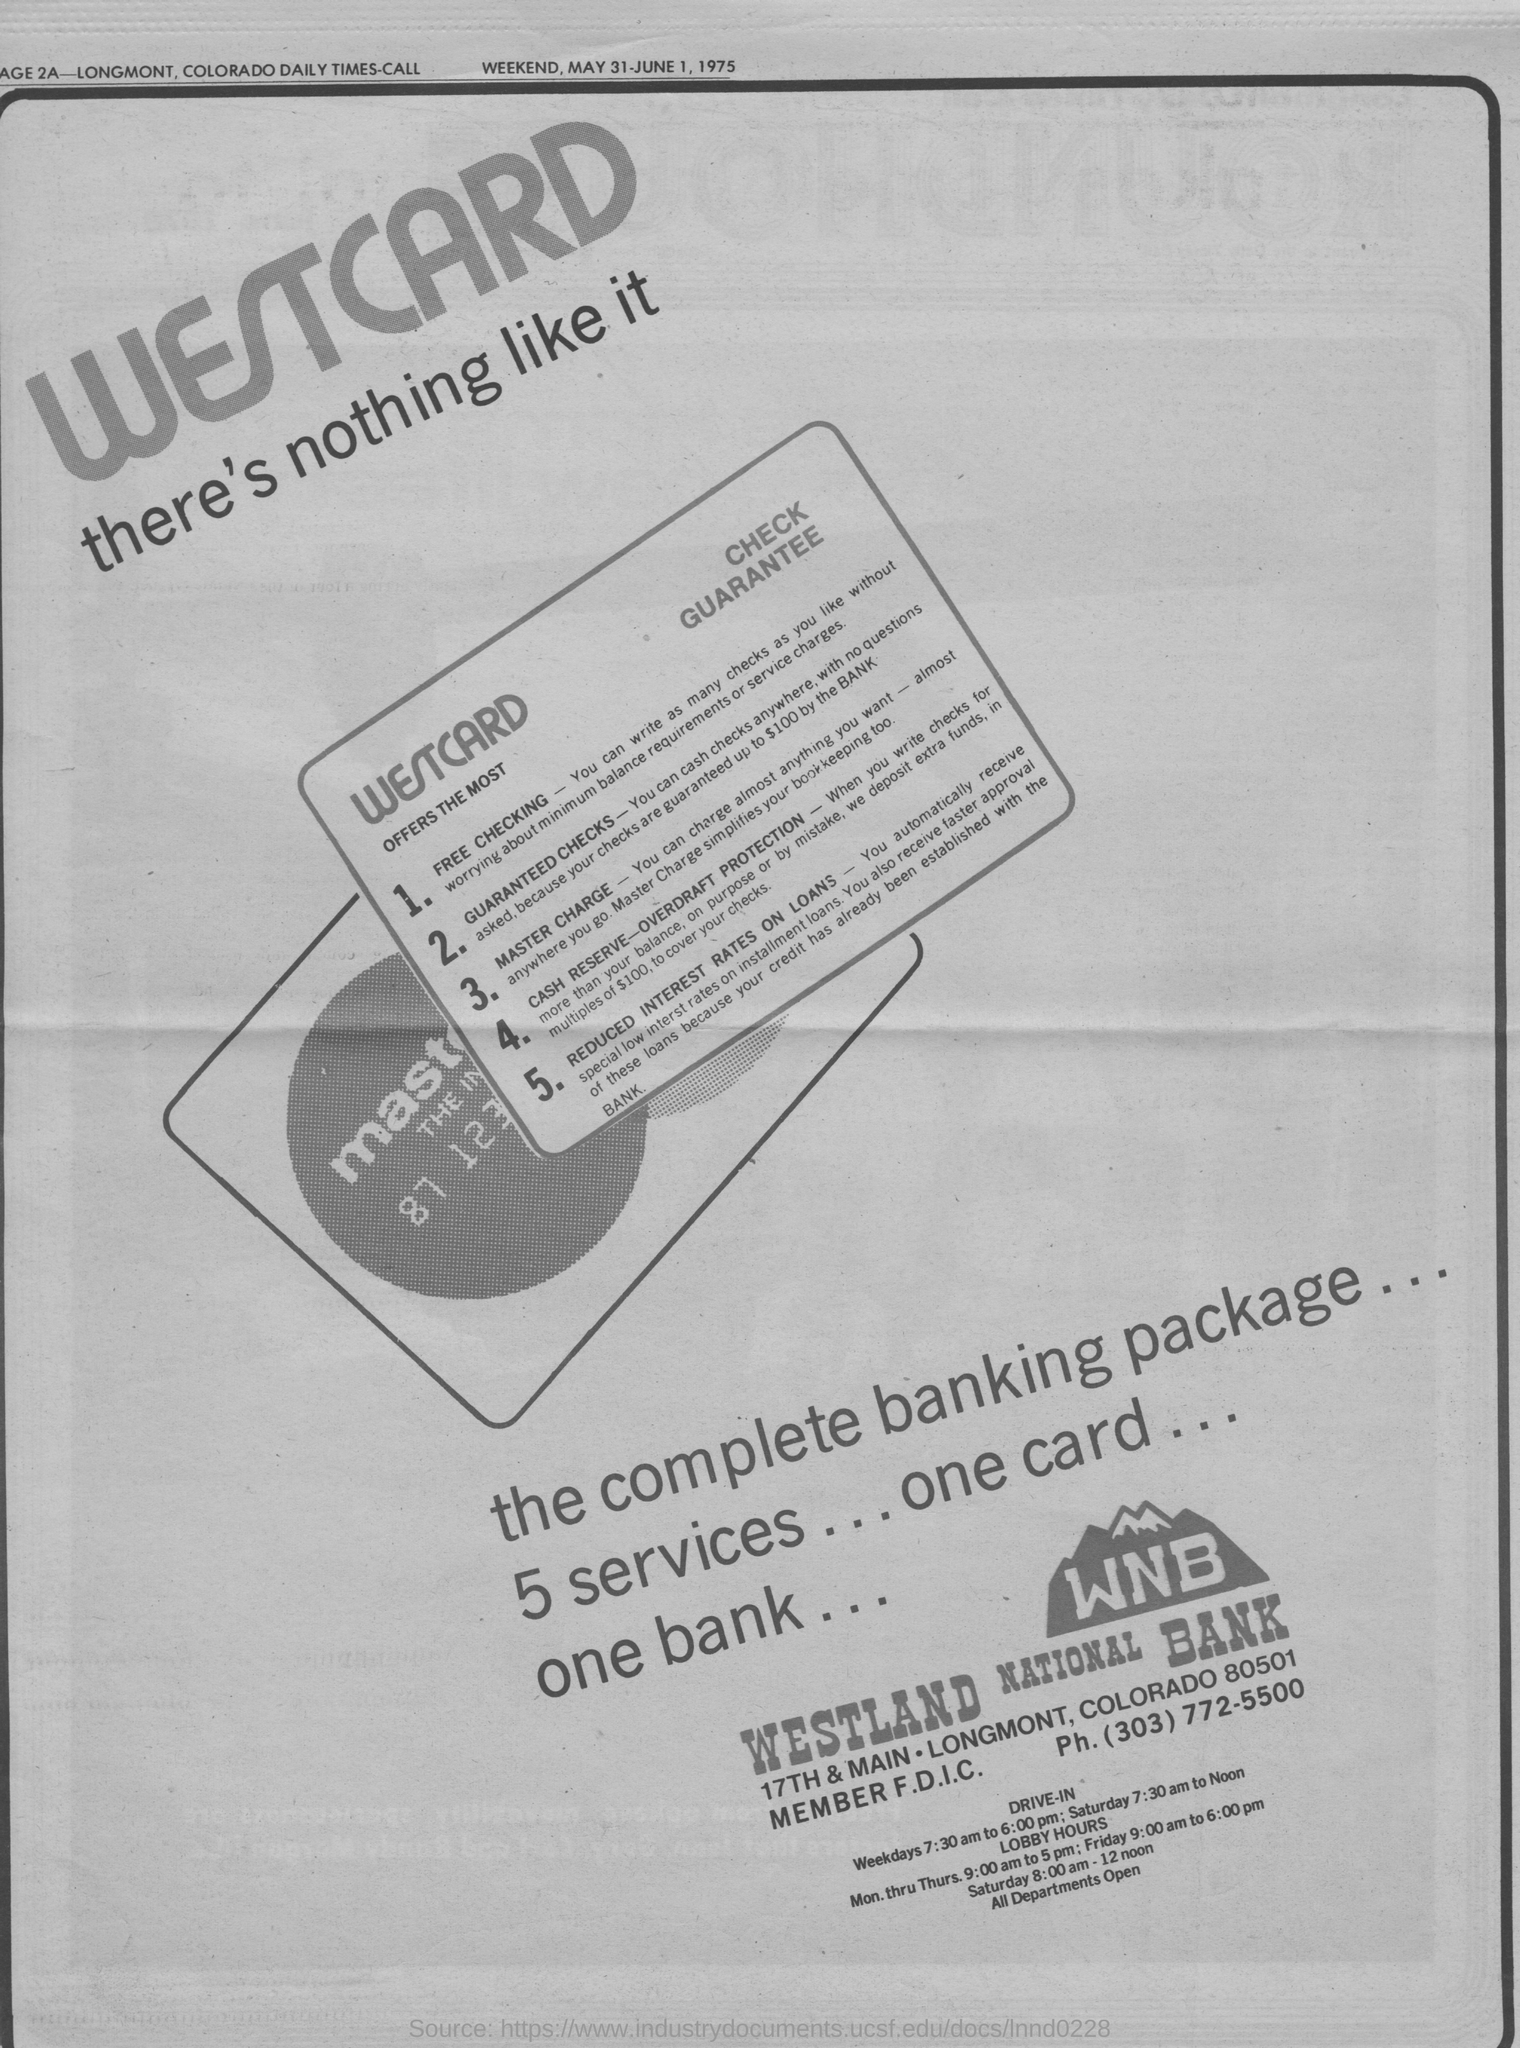When is the article printed on?
Your answer should be compact. WEEKEND, MAY 31-JUNE 1, 1975. What is the advertisement for?
Provide a succinct answer. WESTCARD. Which bank is the advertisement from?
Make the answer very short. WNB. 